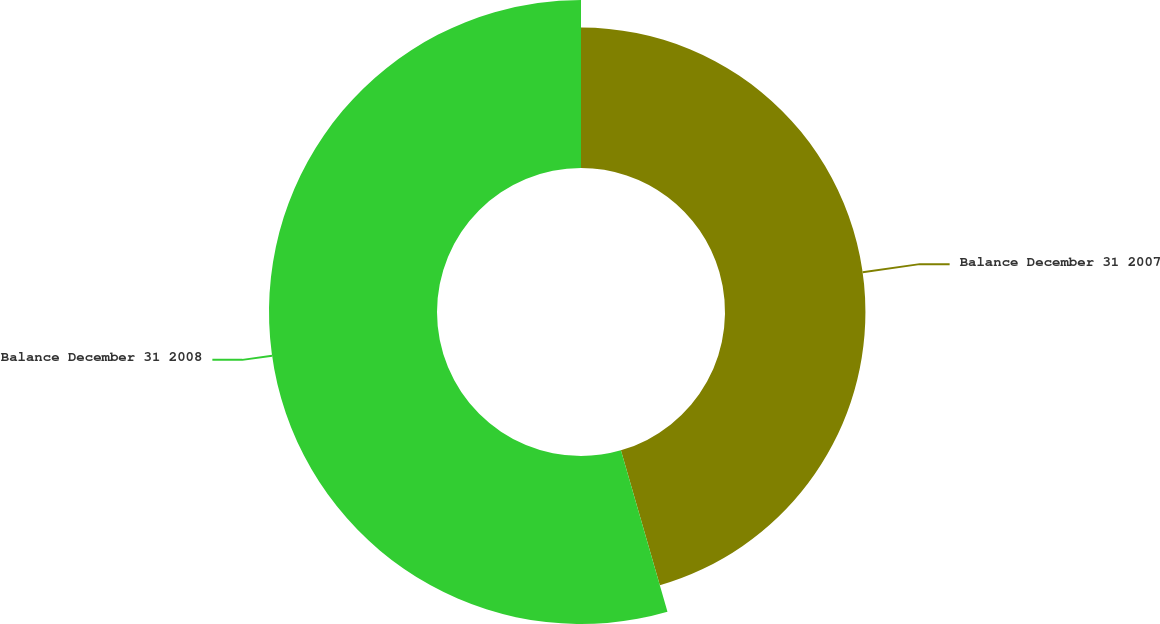Convert chart. <chart><loc_0><loc_0><loc_500><loc_500><pie_chart><fcel>Balance December 31 2007<fcel>Balance December 31 2008<nl><fcel>45.53%<fcel>54.47%<nl></chart> 